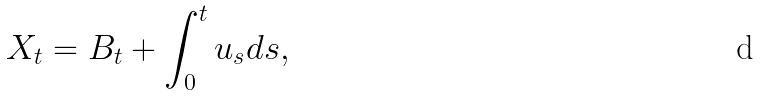Convert formula to latex. <formula><loc_0><loc_0><loc_500><loc_500>X _ { t } = B _ { t } + \int _ { 0 } ^ { t } u _ { s } d s ,</formula> 